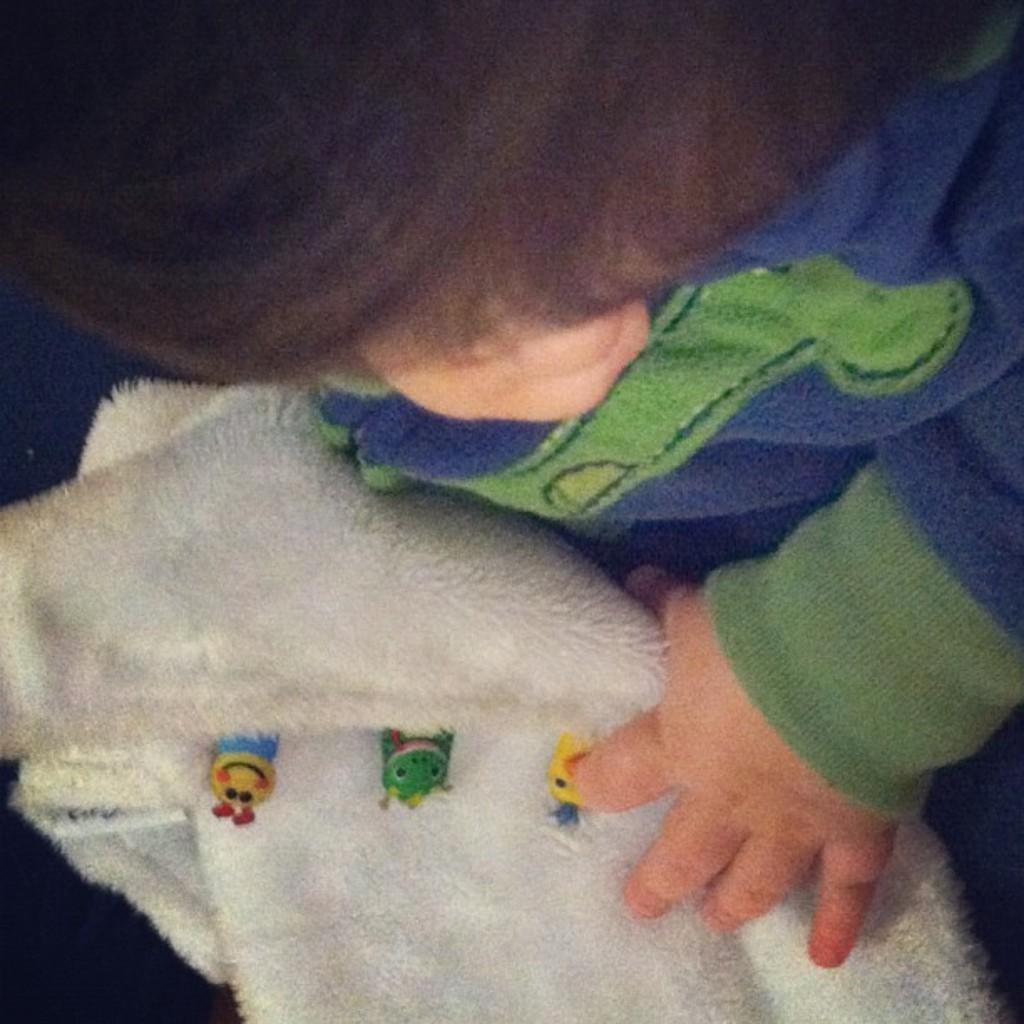Please provide a concise description of this image. In this image there is a baby holding white color cloth. 